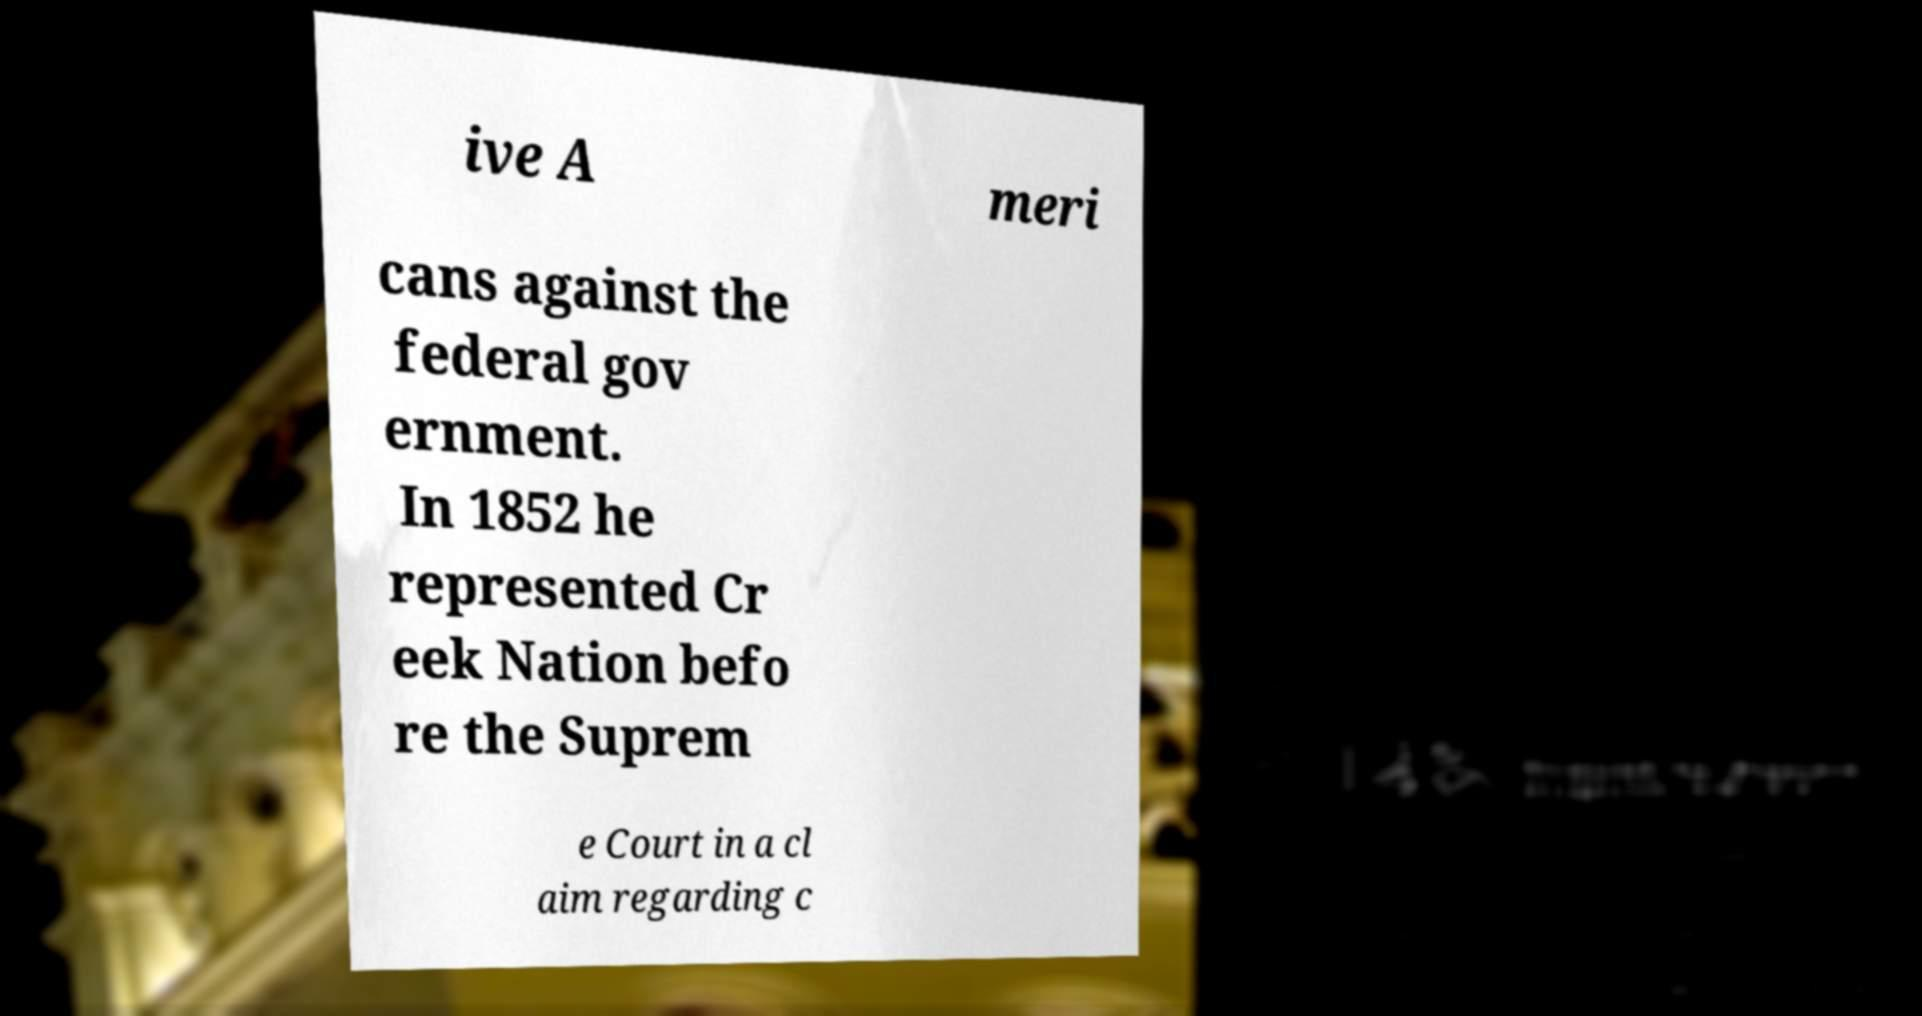Could you extract and type out the text from this image? ive A meri cans against the federal gov ernment. In 1852 he represented Cr eek Nation befo re the Suprem e Court in a cl aim regarding c 